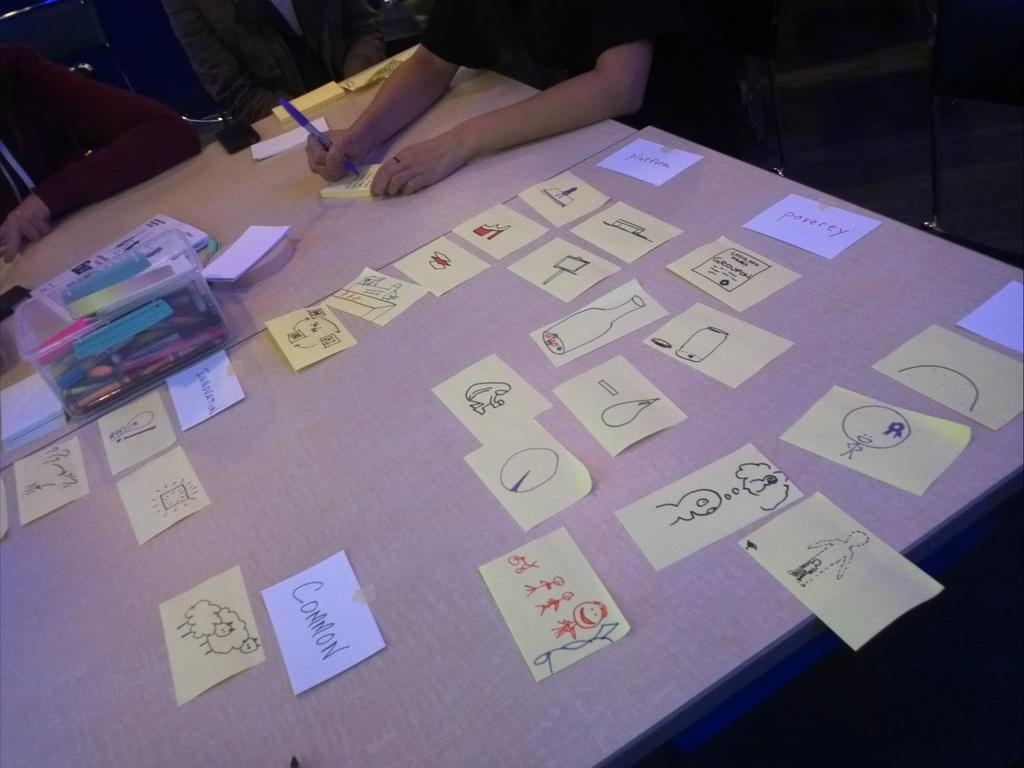What is the person in the image doing? The person is sitting and writing on a paper. What else can be seen near the person? There are other papers beside the person and other objects in front of the person. Can you describe the objects in front of the person? Unfortunately, the provided facts do not specify the nature of the objects in front of the person. What type of juice is the person drinking in the image? There is no juice present in the image; the person is writing on a paper. What type of hook is the person using to hang their meal in the image? There is no hook or meal present in the image; the person is sitting and writing on a paper. 